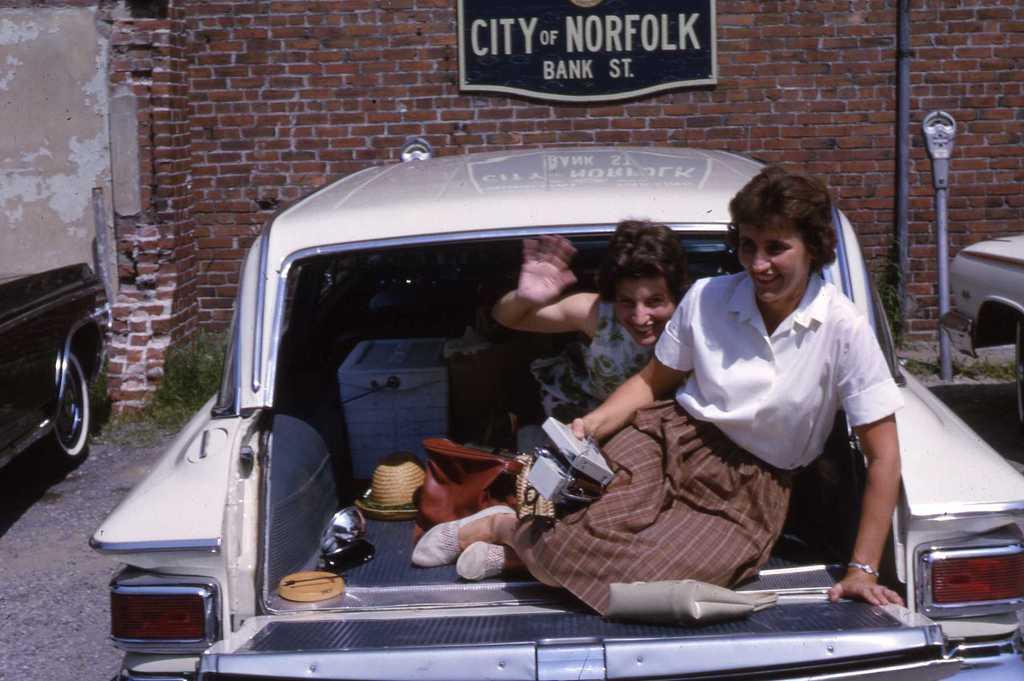How would you summarize this image in a sentence or two? this picture shows two women seated in the trunk of a car and we see a handbag and hats in it and we see a wall all and few cars parked on the side 